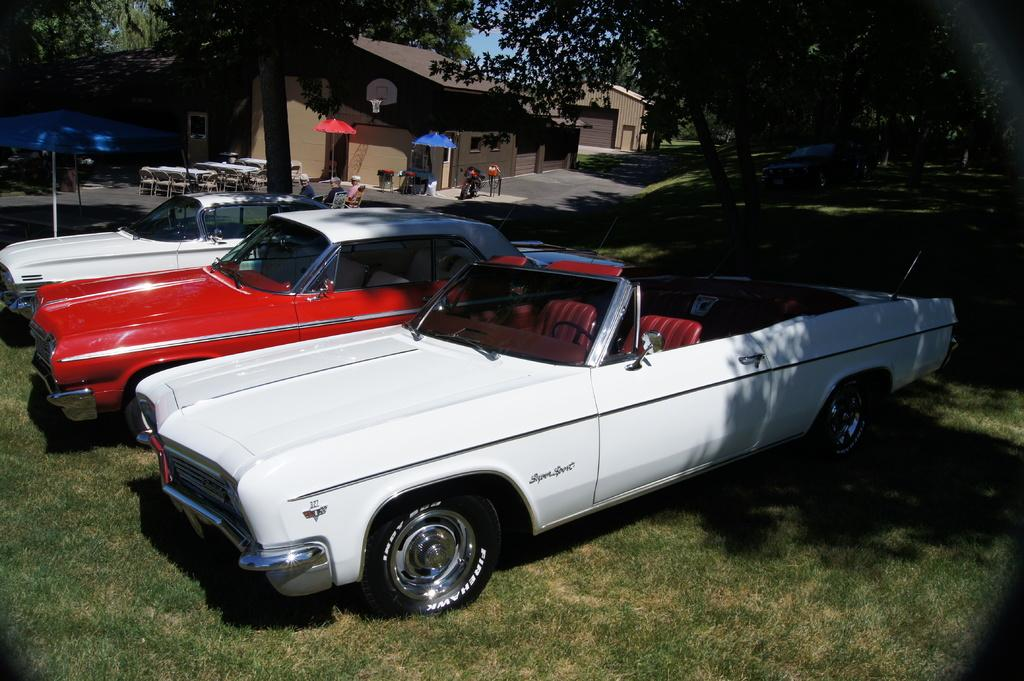What is located in the center of the image? There are cars and parasols in the center of the image. What can be found in the background of the image? There are tables and chairs in the background of the image. What type of vegetation is present in the image? There are trees and grass in the image. What else can be seen in the image besides the cars, parasols, tables, chairs, trees, and grass? There are seeds in the image. Is there a man sleeping on the grass in the image? There is no man sleeping on the grass in the image. What type of plastic objects can be seen in the image? There is no plastic present in the image. 